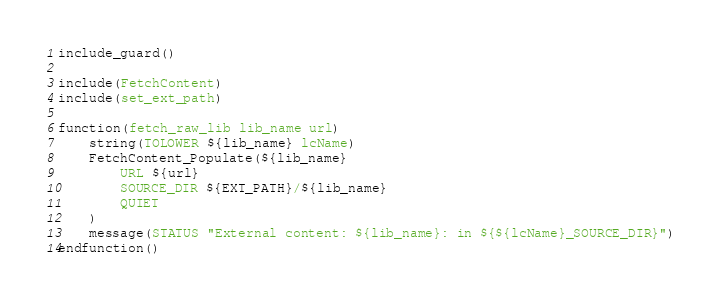<code> <loc_0><loc_0><loc_500><loc_500><_CMake_>include_guard()

include(FetchContent)
include(set_ext_path)

function(fetch_raw_lib lib_name url)
	string(TOLOWER ${lib_name} lcName)
	FetchContent_Populate(${lib_name}
		URL ${url}
		SOURCE_DIR ${EXT_PATH}/${lib_name}
		QUIET
	)
	message(STATUS "External content: ${lib_name}: in ${${lcName}_SOURCE_DIR}")
endfunction()
</code> 